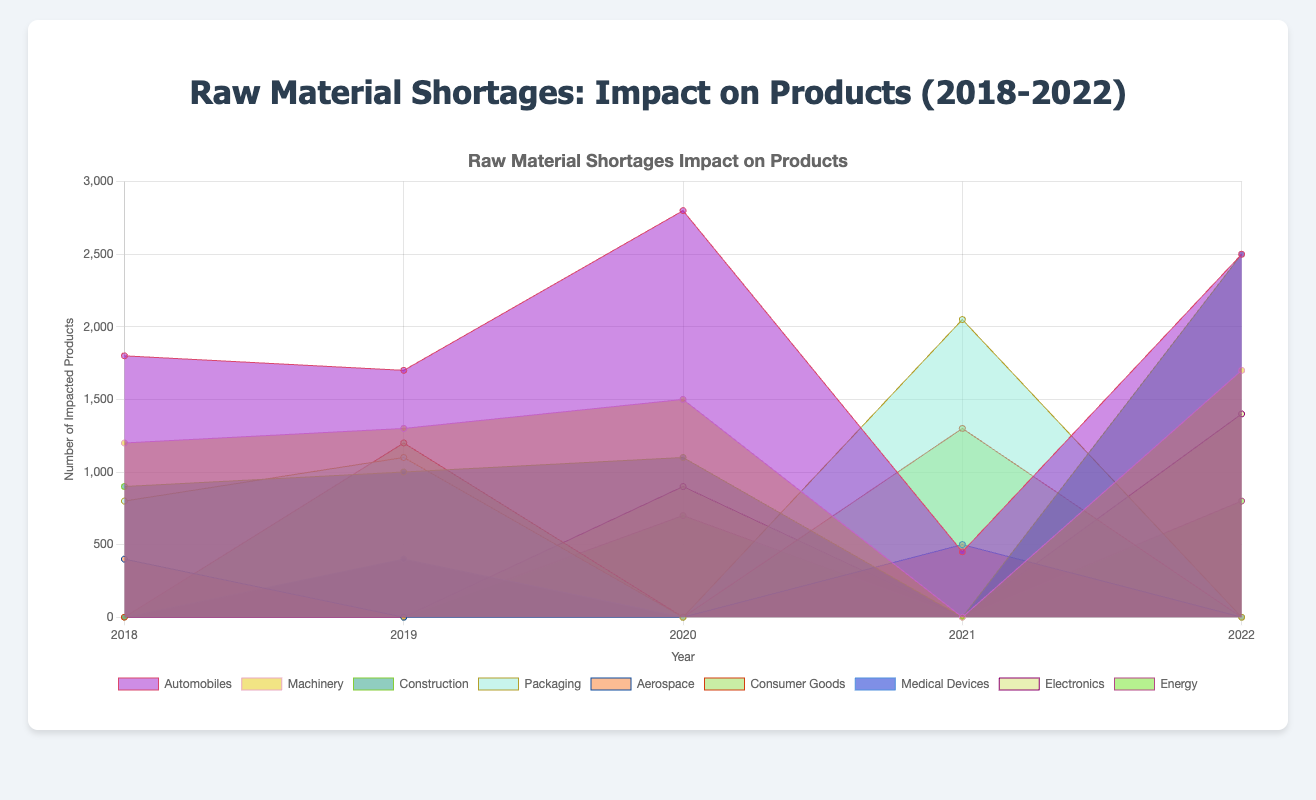What's the title of the chart? The title of the chart is displayed at the top of the figure, providing a summary of the entire visual representation.
Answer: Raw Material Shortages: Impact on Products (2018-2022) How many years of data are represented in the chart? The x-axis of the chart lists the years, which can be counted to identify the range of time the data covers.
Answer: 5 Which raw material caused the highest impact on Automobiles in 2020? To find the answer, look for the line or area graph corresponding to Automobiles in 2020 and identify the raw material with the highest value.
Answer: Steel What is the total number of impacted products for Automobiles in 2022? Sum the values associated with Automobiles in 2022 from different raw materials.
Answer: 2500 + 800 = 3300 Which product had the least impact from raw material shortages in 2018? Identify the product with the smallest area or value under the year 2018 in the chart.
Answer: Aerospace Is the number of impacted products for Construction increasing or decreasing from 2018 to 2022? Observe the trend of the area or line representing Construction from 2018 through 2022 to identify whether the values are generally increasing or decreasing.
Answer: Increasing Which year had the highest overall impact on Machinery due to raw material shortages? Compare the heights of the areas representing Machinery for all the years and identify the year with the highest value.
Answer: 2022 How did the impact on Packaging compare between Aluminum shortages in 2018 and 2021? Look at the values for Packaging due to Aluminum shortages in both 2018 and 2021 and compare them.
Answer: The impact increased from 800 in 2018 to 850 in 2021 What was the combined impact of rare earth elements on Automobiles, Electronics, and Energy in 2020? Sum the values corresponding to Automobiles, Electronics, and Energy under rare earth elements in 2020.
Answer: 800 + 900 + 700 = 2400 How does the impact of plastic shortages on Consumer Goods in 2021 compare to 2019? Identify the values for Consumer Goods caused by Plastic shortages in 2021 and 2019 and compare them.
Answer: 1300 in 2021 is greater than 1200 in 2019 